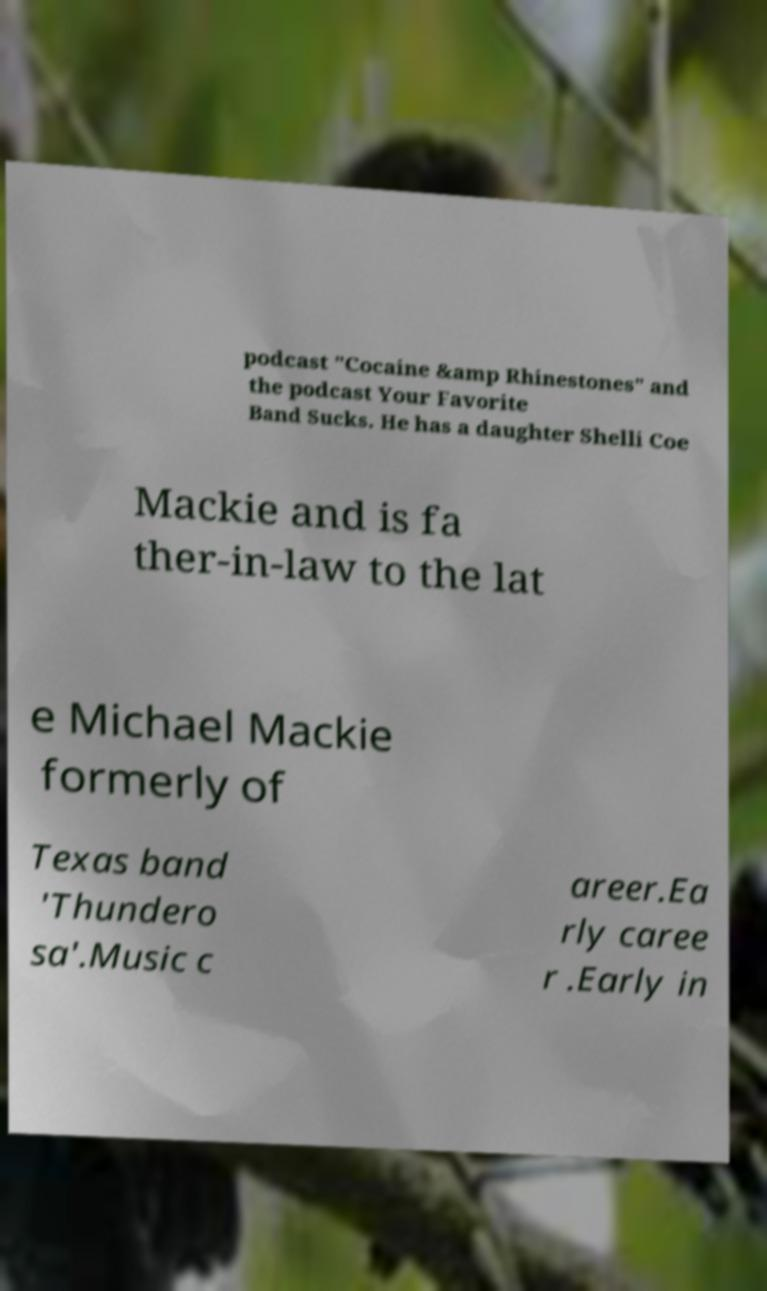Could you assist in decoding the text presented in this image and type it out clearly? podcast "Cocaine &amp Rhinestones" and the podcast Your Favorite Band Sucks. He has a daughter Shelli Coe Mackie and is fa ther-in-law to the lat e Michael Mackie formerly of Texas band 'Thundero sa'.Music c areer.Ea rly caree r .Early in 